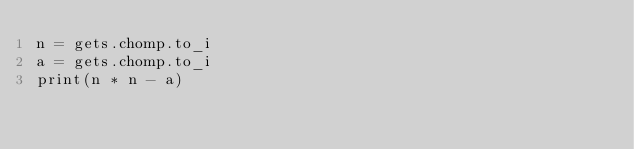<code> <loc_0><loc_0><loc_500><loc_500><_Ruby_>n = gets.chomp.to_i
a = gets.chomp.to_i
print(n * n - a)</code> 